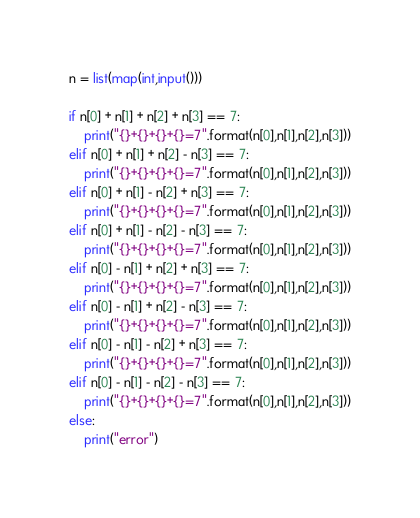<code> <loc_0><loc_0><loc_500><loc_500><_Python_>n = list(map(int,input()))

if n[0] + n[1] + n[2] + n[3] == 7:
    print("{}+{}+{}+{}=7".format(n[0],n[1],n[2],n[3]))
elif n[0] + n[1] + n[2] - n[3] == 7:
    print("{}+{}+{}+{}=7".format(n[0],n[1],n[2],n[3]))
elif n[0] + n[1] - n[2] + n[3] == 7:
    print("{}+{}+{}+{}=7".format(n[0],n[1],n[2],n[3]))
elif n[0] + n[1] - n[2] - n[3] == 7:
    print("{}+{}+{}+{}=7".format(n[0],n[1],n[2],n[3]))
elif n[0] - n[1] + n[2] + n[3] == 7:
    print("{}+{}+{}+{}=7".format(n[0],n[1],n[2],n[3]))
elif n[0] - n[1] + n[2] - n[3] == 7:
    print("{}+{}+{}+{}=7".format(n[0],n[1],n[2],n[3]))
elif n[0] - n[1] - n[2] + n[3] == 7:
    print("{}+{}+{}+{}=7".format(n[0],n[1],n[2],n[3]))
elif n[0] - n[1] - n[2] - n[3] == 7:
    print("{}+{}+{}+{}=7".format(n[0],n[1],n[2],n[3]))
else:
    print("error")
</code> 